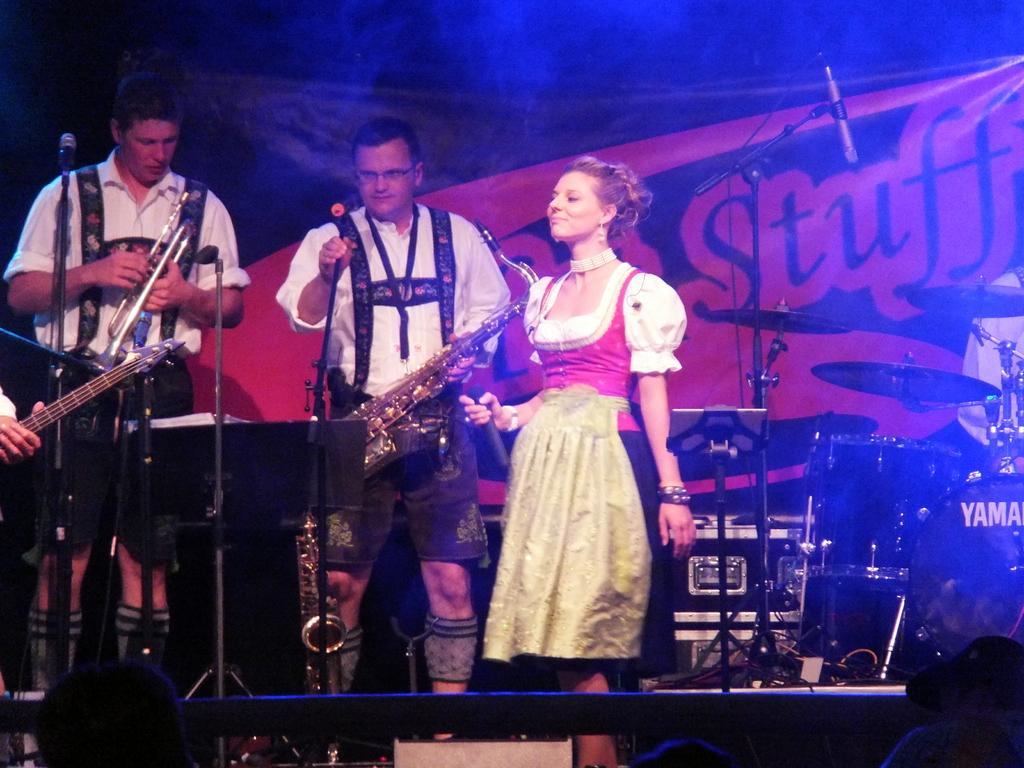How many people are present in the image? There are three people in the image, two men and a woman. What are the individuals in the image doing? The individuals are performing with musical instruments. Can you describe the woman's role in the performance? The woman is holding a microphone in her hand. What color of paint is being used by the woman in the image? There is no paint present in the image; the woman is holding a microphone. Can you tell me how many stalks of celery are on the table in the image? There is no table or celery present in the image. 